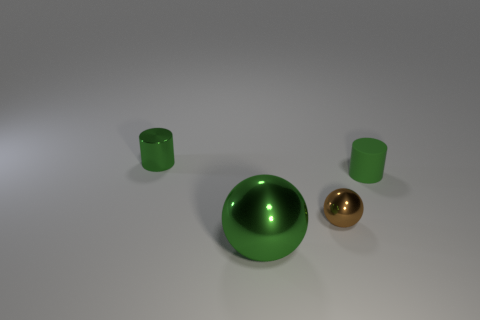Add 2 balls. How many objects exist? 6 Subtract all big objects. Subtract all matte cylinders. How many objects are left? 2 Add 4 tiny metal things. How many tiny metal things are left? 6 Add 2 big green things. How many big green things exist? 3 Subtract 0 blue cubes. How many objects are left? 4 